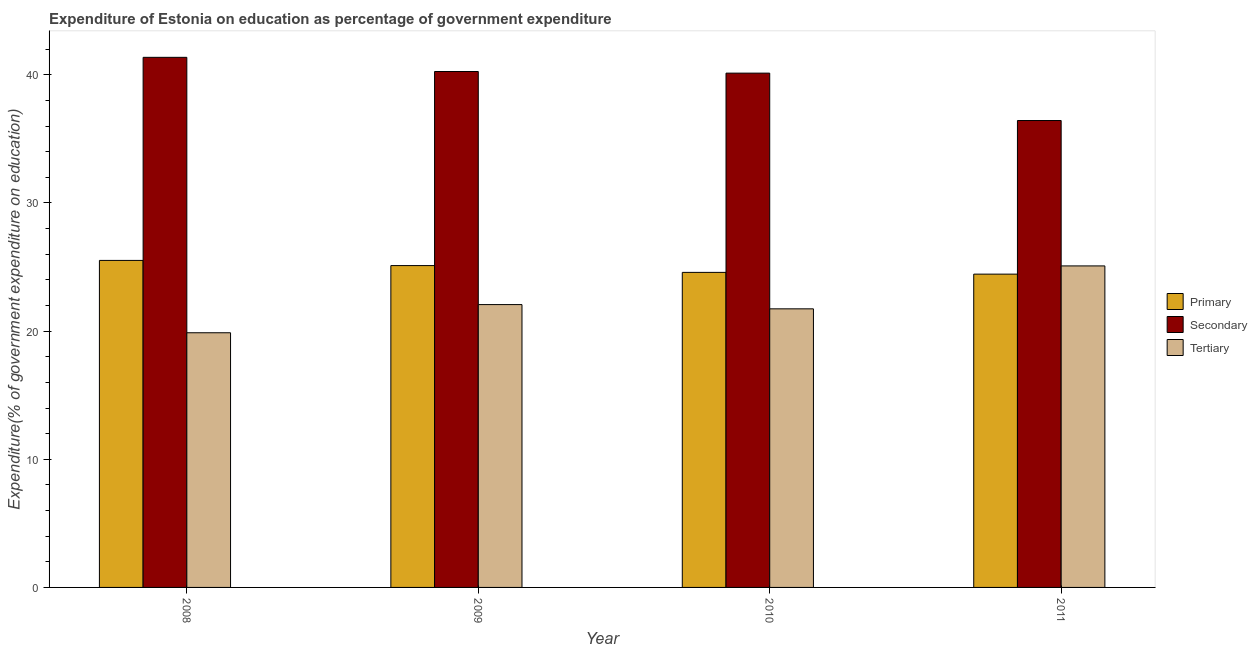How many different coloured bars are there?
Offer a very short reply. 3. Are the number of bars per tick equal to the number of legend labels?
Make the answer very short. Yes. What is the label of the 4th group of bars from the left?
Give a very brief answer. 2011. What is the expenditure on secondary education in 2010?
Offer a terse response. 40.13. Across all years, what is the maximum expenditure on secondary education?
Ensure brevity in your answer.  41.36. Across all years, what is the minimum expenditure on tertiary education?
Your answer should be compact. 19.87. In which year was the expenditure on tertiary education maximum?
Offer a terse response. 2011. What is the total expenditure on primary education in the graph?
Your answer should be compact. 99.65. What is the difference between the expenditure on tertiary education in 2009 and that in 2010?
Offer a very short reply. 0.33. What is the difference between the expenditure on primary education in 2011 and the expenditure on tertiary education in 2009?
Give a very brief answer. -0.67. What is the average expenditure on primary education per year?
Your answer should be compact. 24.91. In the year 2011, what is the difference between the expenditure on primary education and expenditure on secondary education?
Give a very brief answer. 0. What is the ratio of the expenditure on primary education in 2008 to that in 2009?
Your answer should be very brief. 1.02. What is the difference between the highest and the second highest expenditure on tertiary education?
Your answer should be compact. 3.02. What is the difference between the highest and the lowest expenditure on primary education?
Keep it short and to the point. 1.07. In how many years, is the expenditure on secondary education greater than the average expenditure on secondary education taken over all years?
Provide a short and direct response. 3. What does the 2nd bar from the left in 2009 represents?
Ensure brevity in your answer.  Secondary. What does the 2nd bar from the right in 2010 represents?
Provide a short and direct response. Secondary. Is it the case that in every year, the sum of the expenditure on primary education and expenditure on secondary education is greater than the expenditure on tertiary education?
Ensure brevity in your answer.  Yes. How many years are there in the graph?
Provide a short and direct response. 4. Does the graph contain any zero values?
Ensure brevity in your answer.  No. How many legend labels are there?
Keep it short and to the point. 3. How are the legend labels stacked?
Provide a short and direct response. Vertical. What is the title of the graph?
Your answer should be very brief. Expenditure of Estonia on education as percentage of government expenditure. What is the label or title of the X-axis?
Make the answer very short. Year. What is the label or title of the Y-axis?
Your response must be concise. Expenditure(% of government expenditure on education). What is the Expenditure(% of government expenditure on education) of Primary in 2008?
Provide a short and direct response. 25.52. What is the Expenditure(% of government expenditure on education) of Secondary in 2008?
Keep it short and to the point. 41.36. What is the Expenditure(% of government expenditure on education) of Tertiary in 2008?
Offer a terse response. 19.87. What is the Expenditure(% of government expenditure on education) in Primary in 2009?
Make the answer very short. 25.11. What is the Expenditure(% of government expenditure on education) of Secondary in 2009?
Make the answer very short. 40.25. What is the Expenditure(% of government expenditure on education) of Tertiary in 2009?
Your answer should be very brief. 22.07. What is the Expenditure(% of government expenditure on education) of Primary in 2010?
Offer a very short reply. 24.58. What is the Expenditure(% of government expenditure on education) in Secondary in 2010?
Make the answer very short. 40.13. What is the Expenditure(% of government expenditure on education) of Tertiary in 2010?
Offer a very short reply. 21.74. What is the Expenditure(% of government expenditure on education) in Primary in 2011?
Provide a succinct answer. 24.45. What is the Expenditure(% of government expenditure on education) in Secondary in 2011?
Your answer should be very brief. 36.43. What is the Expenditure(% of government expenditure on education) of Tertiary in 2011?
Keep it short and to the point. 25.09. Across all years, what is the maximum Expenditure(% of government expenditure on education) of Primary?
Provide a short and direct response. 25.52. Across all years, what is the maximum Expenditure(% of government expenditure on education) of Secondary?
Ensure brevity in your answer.  41.36. Across all years, what is the maximum Expenditure(% of government expenditure on education) in Tertiary?
Provide a succinct answer. 25.09. Across all years, what is the minimum Expenditure(% of government expenditure on education) of Primary?
Make the answer very short. 24.45. Across all years, what is the minimum Expenditure(% of government expenditure on education) in Secondary?
Keep it short and to the point. 36.43. Across all years, what is the minimum Expenditure(% of government expenditure on education) in Tertiary?
Ensure brevity in your answer.  19.87. What is the total Expenditure(% of government expenditure on education) in Primary in the graph?
Make the answer very short. 99.65. What is the total Expenditure(% of government expenditure on education) in Secondary in the graph?
Offer a very short reply. 158.18. What is the total Expenditure(% of government expenditure on education) of Tertiary in the graph?
Offer a very short reply. 88.76. What is the difference between the Expenditure(% of government expenditure on education) of Primary in 2008 and that in 2009?
Provide a short and direct response. 0.4. What is the difference between the Expenditure(% of government expenditure on education) of Secondary in 2008 and that in 2009?
Make the answer very short. 1.11. What is the difference between the Expenditure(% of government expenditure on education) of Tertiary in 2008 and that in 2009?
Give a very brief answer. -2.2. What is the difference between the Expenditure(% of government expenditure on education) in Primary in 2008 and that in 2010?
Offer a terse response. 0.93. What is the difference between the Expenditure(% of government expenditure on education) in Secondary in 2008 and that in 2010?
Provide a short and direct response. 1.23. What is the difference between the Expenditure(% of government expenditure on education) in Tertiary in 2008 and that in 2010?
Keep it short and to the point. -1.87. What is the difference between the Expenditure(% of government expenditure on education) in Primary in 2008 and that in 2011?
Give a very brief answer. 1.07. What is the difference between the Expenditure(% of government expenditure on education) of Secondary in 2008 and that in 2011?
Provide a succinct answer. 4.93. What is the difference between the Expenditure(% of government expenditure on education) of Tertiary in 2008 and that in 2011?
Your answer should be compact. -5.21. What is the difference between the Expenditure(% of government expenditure on education) in Primary in 2009 and that in 2010?
Your response must be concise. 0.53. What is the difference between the Expenditure(% of government expenditure on education) of Secondary in 2009 and that in 2010?
Ensure brevity in your answer.  0.13. What is the difference between the Expenditure(% of government expenditure on education) of Tertiary in 2009 and that in 2010?
Offer a very short reply. 0.33. What is the difference between the Expenditure(% of government expenditure on education) in Primary in 2009 and that in 2011?
Offer a terse response. 0.67. What is the difference between the Expenditure(% of government expenditure on education) of Secondary in 2009 and that in 2011?
Give a very brief answer. 3.82. What is the difference between the Expenditure(% of government expenditure on education) of Tertiary in 2009 and that in 2011?
Your answer should be compact. -3.02. What is the difference between the Expenditure(% of government expenditure on education) in Primary in 2010 and that in 2011?
Offer a very short reply. 0.14. What is the difference between the Expenditure(% of government expenditure on education) in Secondary in 2010 and that in 2011?
Your answer should be very brief. 3.7. What is the difference between the Expenditure(% of government expenditure on education) of Tertiary in 2010 and that in 2011?
Give a very brief answer. -3.35. What is the difference between the Expenditure(% of government expenditure on education) of Primary in 2008 and the Expenditure(% of government expenditure on education) of Secondary in 2009?
Keep it short and to the point. -14.74. What is the difference between the Expenditure(% of government expenditure on education) in Primary in 2008 and the Expenditure(% of government expenditure on education) in Tertiary in 2009?
Provide a short and direct response. 3.45. What is the difference between the Expenditure(% of government expenditure on education) of Secondary in 2008 and the Expenditure(% of government expenditure on education) of Tertiary in 2009?
Provide a short and direct response. 19.29. What is the difference between the Expenditure(% of government expenditure on education) in Primary in 2008 and the Expenditure(% of government expenditure on education) in Secondary in 2010?
Your answer should be very brief. -14.61. What is the difference between the Expenditure(% of government expenditure on education) of Primary in 2008 and the Expenditure(% of government expenditure on education) of Tertiary in 2010?
Give a very brief answer. 3.78. What is the difference between the Expenditure(% of government expenditure on education) of Secondary in 2008 and the Expenditure(% of government expenditure on education) of Tertiary in 2010?
Provide a short and direct response. 19.62. What is the difference between the Expenditure(% of government expenditure on education) in Primary in 2008 and the Expenditure(% of government expenditure on education) in Secondary in 2011?
Provide a succinct answer. -10.91. What is the difference between the Expenditure(% of government expenditure on education) of Primary in 2008 and the Expenditure(% of government expenditure on education) of Tertiary in 2011?
Keep it short and to the point. 0.43. What is the difference between the Expenditure(% of government expenditure on education) in Secondary in 2008 and the Expenditure(% of government expenditure on education) in Tertiary in 2011?
Make the answer very short. 16.28. What is the difference between the Expenditure(% of government expenditure on education) in Primary in 2009 and the Expenditure(% of government expenditure on education) in Secondary in 2010?
Provide a short and direct response. -15.02. What is the difference between the Expenditure(% of government expenditure on education) of Primary in 2009 and the Expenditure(% of government expenditure on education) of Tertiary in 2010?
Give a very brief answer. 3.37. What is the difference between the Expenditure(% of government expenditure on education) in Secondary in 2009 and the Expenditure(% of government expenditure on education) in Tertiary in 2010?
Your response must be concise. 18.52. What is the difference between the Expenditure(% of government expenditure on education) in Primary in 2009 and the Expenditure(% of government expenditure on education) in Secondary in 2011?
Make the answer very short. -11.32. What is the difference between the Expenditure(% of government expenditure on education) in Primary in 2009 and the Expenditure(% of government expenditure on education) in Tertiary in 2011?
Keep it short and to the point. 0.03. What is the difference between the Expenditure(% of government expenditure on education) in Secondary in 2009 and the Expenditure(% of government expenditure on education) in Tertiary in 2011?
Provide a short and direct response. 15.17. What is the difference between the Expenditure(% of government expenditure on education) in Primary in 2010 and the Expenditure(% of government expenditure on education) in Secondary in 2011?
Give a very brief answer. -11.85. What is the difference between the Expenditure(% of government expenditure on education) in Primary in 2010 and the Expenditure(% of government expenditure on education) in Tertiary in 2011?
Offer a very short reply. -0.5. What is the difference between the Expenditure(% of government expenditure on education) of Secondary in 2010 and the Expenditure(% of government expenditure on education) of Tertiary in 2011?
Your answer should be very brief. 15.04. What is the average Expenditure(% of government expenditure on education) in Primary per year?
Offer a very short reply. 24.91. What is the average Expenditure(% of government expenditure on education) in Secondary per year?
Give a very brief answer. 39.54. What is the average Expenditure(% of government expenditure on education) of Tertiary per year?
Give a very brief answer. 22.19. In the year 2008, what is the difference between the Expenditure(% of government expenditure on education) of Primary and Expenditure(% of government expenditure on education) of Secondary?
Your answer should be compact. -15.85. In the year 2008, what is the difference between the Expenditure(% of government expenditure on education) of Primary and Expenditure(% of government expenditure on education) of Tertiary?
Offer a very short reply. 5.64. In the year 2008, what is the difference between the Expenditure(% of government expenditure on education) in Secondary and Expenditure(% of government expenditure on education) in Tertiary?
Ensure brevity in your answer.  21.49. In the year 2009, what is the difference between the Expenditure(% of government expenditure on education) of Primary and Expenditure(% of government expenditure on education) of Secondary?
Give a very brief answer. -15.14. In the year 2009, what is the difference between the Expenditure(% of government expenditure on education) of Primary and Expenditure(% of government expenditure on education) of Tertiary?
Make the answer very short. 3.04. In the year 2009, what is the difference between the Expenditure(% of government expenditure on education) of Secondary and Expenditure(% of government expenditure on education) of Tertiary?
Make the answer very short. 18.19. In the year 2010, what is the difference between the Expenditure(% of government expenditure on education) in Primary and Expenditure(% of government expenditure on education) in Secondary?
Ensure brevity in your answer.  -15.55. In the year 2010, what is the difference between the Expenditure(% of government expenditure on education) of Primary and Expenditure(% of government expenditure on education) of Tertiary?
Your answer should be very brief. 2.84. In the year 2010, what is the difference between the Expenditure(% of government expenditure on education) of Secondary and Expenditure(% of government expenditure on education) of Tertiary?
Keep it short and to the point. 18.39. In the year 2011, what is the difference between the Expenditure(% of government expenditure on education) in Primary and Expenditure(% of government expenditure on education) in Secondary?
Offer a terse response. -11.98. In the year 2011, what is the difference between the Expenditure(% of government expenditure on education) in Primary and Expenditure(% of government expenditure on education) in Tertiary?
Offer a very short reply. -0.64. In the year 2011, what is the difference between the Expenditure(% of government expenditure on education) of Secondary and Expenditure(% of government expenditure on education) of Tertiary?
Your response must be concise. 11.34. What is the ratio of the Expenditure(% of government expenditure on education) of Primary in 2008 to that in 2009?
Offer a very short reply. 1.02. What is the ratio of the Expenditure(% of government expenditure on education) in Secondary in 2008 to that in 2009?
Offer a very short reply. 1.03. What is the ratio of the Expenditure(% of government expenditure on education) of Tertiary in 2008 to that in 2009?
Provide a succinct answer. 0.9. What is the ratio of the Expenditure(% of government expenditure on education) of Primary in 2008 to that in 2010?
Your answer should be compact. 1.04. What is the ratio of the Expenditure(% of government expenditure on education) of Secondary in 2008 to that in 2010?
Provide a succinct answer. 1.03. What is the ratio of the Expenditure(% of government expenditure on education) in Tertiary in 2008 to that in 2010?
Your answer should be very brief. 0.91. What is the ratio of the Expenditure(% of government expenditure on education) in Primary in 2008 to that in 2011?
Your response must be concise. 1.04. What is the ratio of the Expenditure(% of government expenditure on education) in Secondary in 2008 to that in 2011?
Give a very brief answer. 1.14. What is the ratio of the Expenditure(% of government expenditure on education) of Tertiary in 2008 to that in 2011?
Offer a very short reply. 0.79. What is the ratio of the Expenditure(% of government expenditure on education) in Primary in 2009 to that in 2010?
Make the answer very short. 1.02. What is the ratio of the Expenditure(% of government expenditure on education) of Secondary in 2009 to that in 2010?
Your answer should be compact. 1. What is the ratio of the Expenditure(% of government expenditure on education) of Tertiary in 2009 to that in 2010?
Your response must be concise. 1.02. What is the ratio of the Expenditure(% of government expenditure on education) in Primary in 2009 to that in 2011?
Keep it short and to the point. 1.03. What is the ratio of the Expenditure(% of government expenditure on education) of Secondary in 2009 to that in 2011?
Make the answer very short. 1.1. What is the ratio of the Expenditure(% of government expenditure on education) of Tertiary in 2009 to that in 2011?
Provide a succinct answer. 0.88. What is the ratio of the Expenditure(% of government expenditure on education) in Primary in 2010 to that in 2011?
Provide a succinct answer. 1.01. What is the ratio of the Expenditure(% of government expenditure on education) in Secondary in 2010 to that in 2011?
Offer a very short reply. 1.1. What is the ratio of the Expenditure(% of government expenditure on education) in Tertiary in 2010 to that in 2011?
Your answer should be very brief. 0.87. What is the difference between the highest and the second highest Expenditure(% of government expenditure on education) in Primary?
Ensure brevity in your answer.  0.4. What is the difference between the highest and the second highest Expenditure(% of government expenditure on education) of Secondary?
Ensure brevity in your answer.  1.11. What is the difference between the highest and the second highest Expenditure(% of government expenditure on education) of Tertiary?
Give a very brief answer. 3.02. What is the difference between the highest and the lowest Expenditure(% of government expenditure on education) of Primary?
Provide a short and direct response. 1.07. What is the difference between the highest and the lowest Expenditure(% of government expenditure on education) of Secondary?
Your response must be concise. 4.93. What is the difference between the highest and the lowest Expenditure(% of government expenditure on education) of Tertiary?
Your response must be concise. 5.21. 